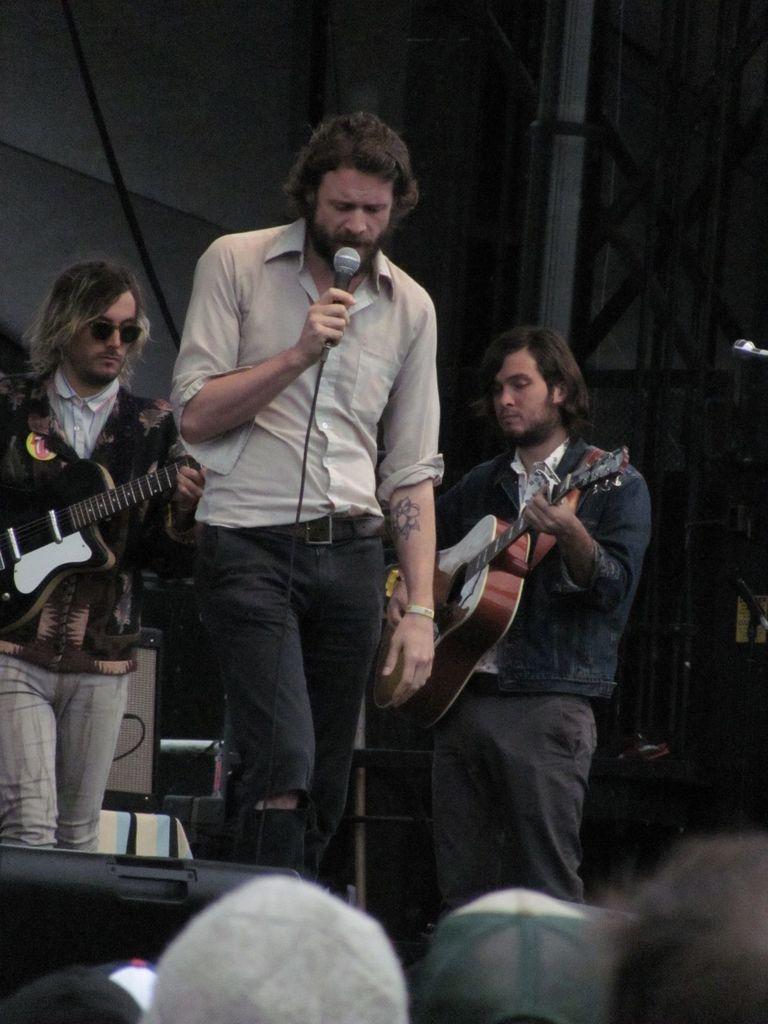Describe this image in one or two sentences. In this image, In the middle there is a man standing and he is holding a microphone and he is singing in the microphone, There are some people standing and holding the music instruments and in the background there is a white color wall, In the bottom there are some people standing and they are listening. 